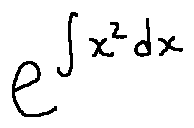<formula> <loc_0><loc_0><loc_500><loc_500>e ^ { \int x ^ { 2 } d x }</formula> 